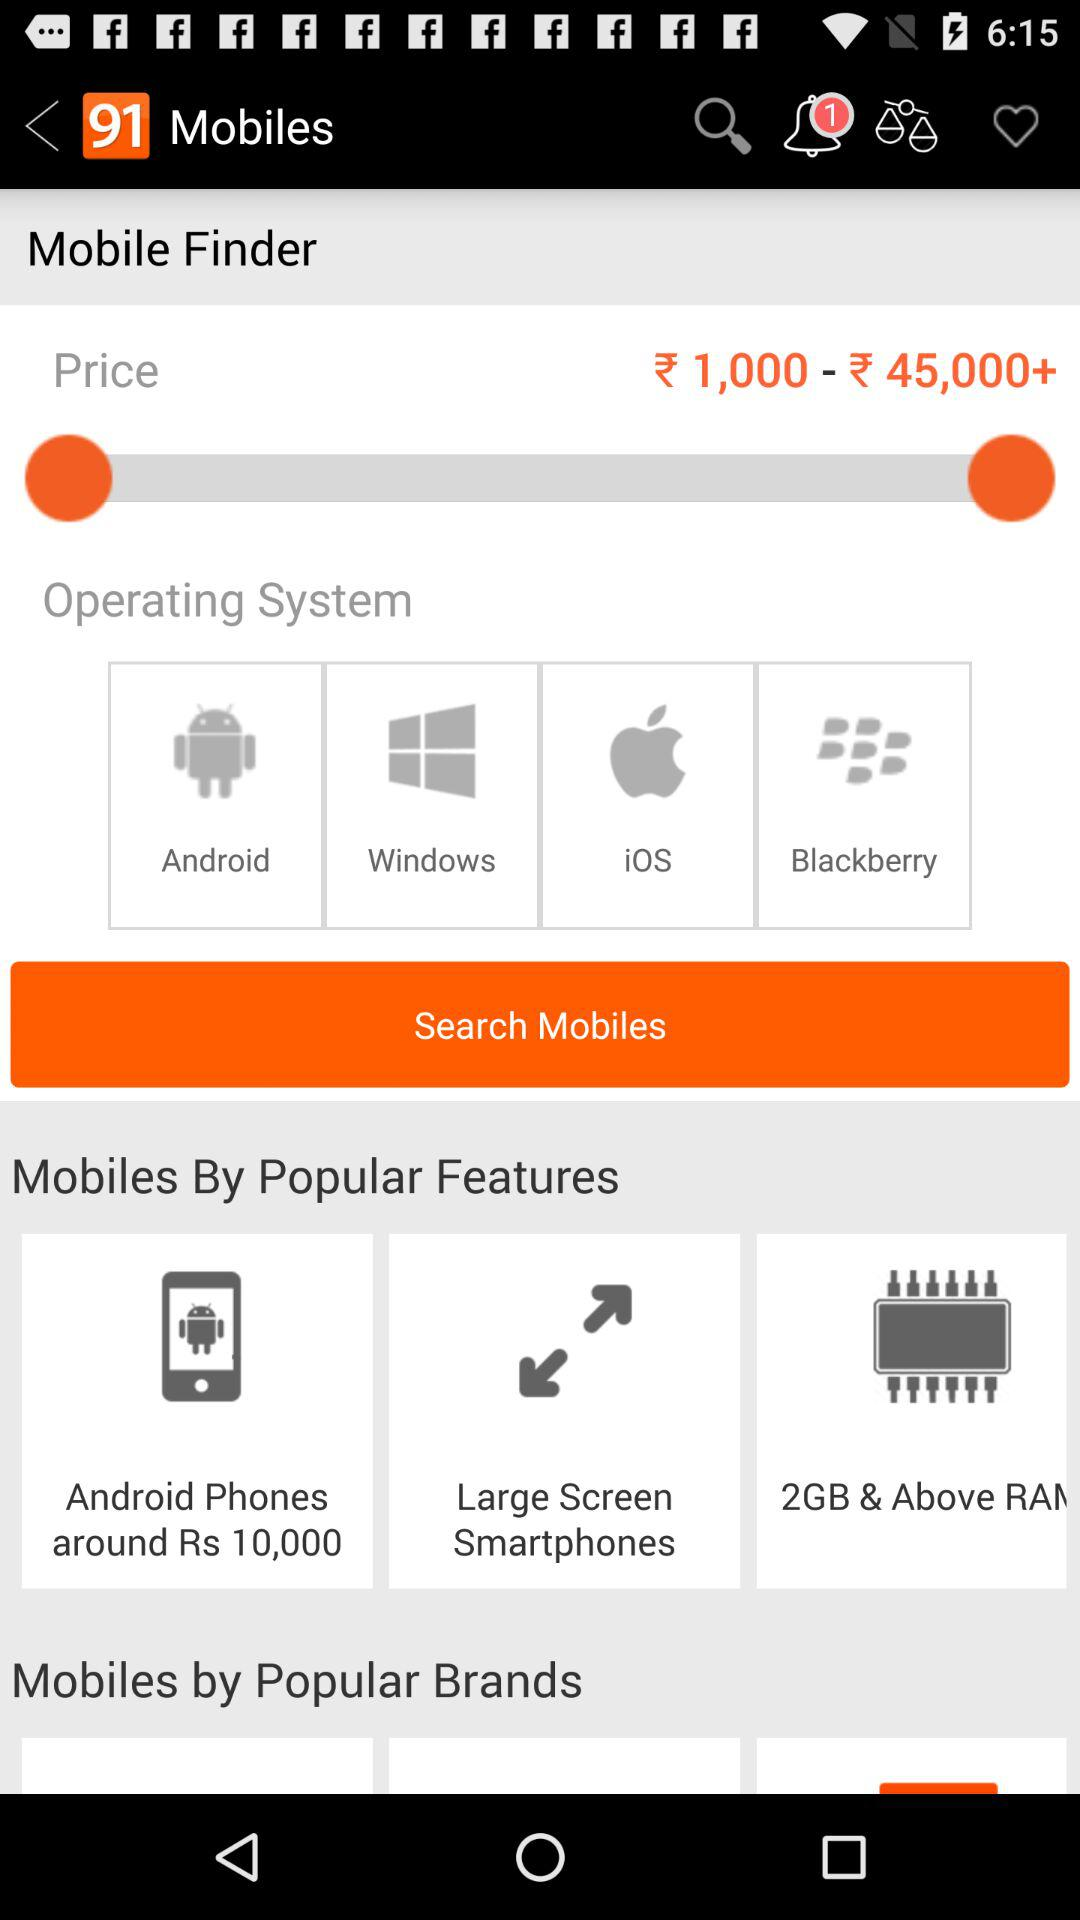What is the price range? The price range is from ₹ 1,000 to more than ₹ 45,000. 